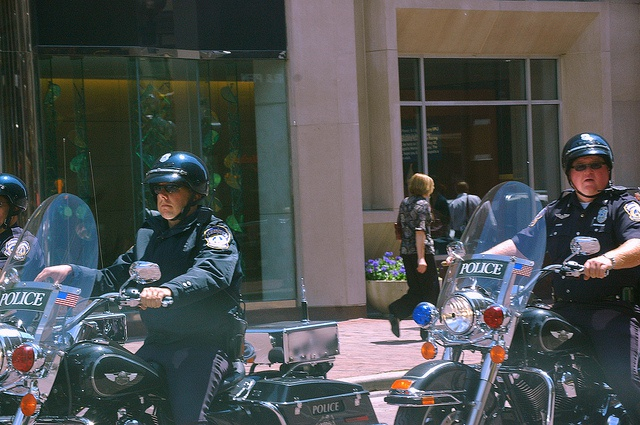Describe the objects in this image and their specific colors. I can see motorcycle in black, blue, gray, and darkgray tones, motorcycle in black, gray, and blue tones, people in black, purple, darkblue, and gray tones, people in black, blue, gray, and lavender tones, and people in black and gray tones in this image. 